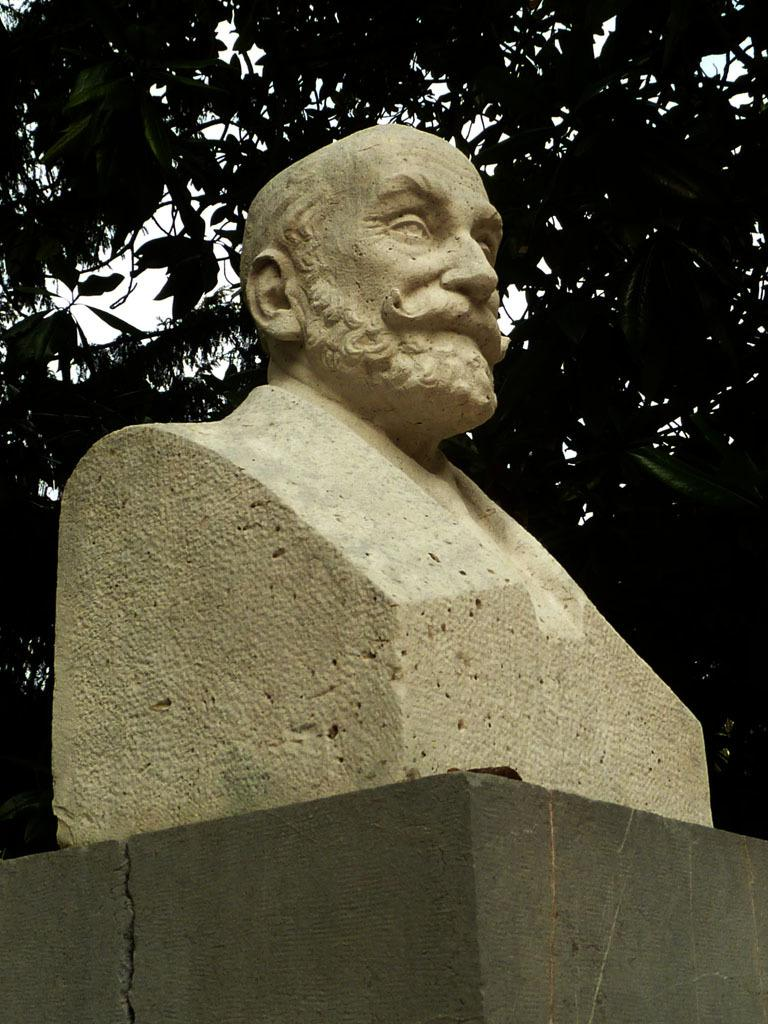What is the main structure in the image? There is a pillar in the image. What is on top of the pillar? There is a statue on top of the pillar. What can be seen in the background of the image? There are trees in the background of the image. What is visible at the top of the image? The sky is visible at the top of the image. What time of day is it in the image, as indicated by the position of the needle on a clock? There is no clock or needle present in the image, so it is not possible to determine the time of day. 